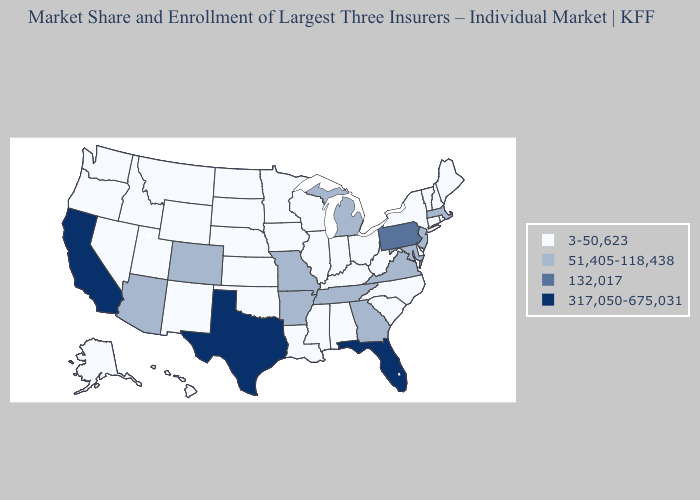Name the states that have a value in the range 132,017?
Keep it brief. Pennsylvania. Does Pennsylvania have the highest value in the Northeast?
Short answer required. Yes. Does Maine have the lowest value in the USA?
Concise answer only. Yes. Name the states that have a value in the range 132,017?
Concise answer only. Pennsylvania. Name the states that have a value in the range 3-50,623?
Give a very brief answer. Alabama, Alaska, Connecticut, Delaware, Hawaii, Idaho, Illinois, Indiana, Iowa, Kansas, Kentucky, Louisiana, Maine, Minnesota, Mississippi, Montana, Nebraska, Nevada, New Hampshire, New Mexico, New York, North Carolina, North Dakota, Ohio, Oklahoma, Oregon, Rhode Island, South Carolina, South Dakota, Utah, Vermont, Washington, West Virginia, Wisconsin, Wyoming. Which states hav the highest value in the West?
Short answer required. California. Which states have the highest value in the USA?
Concise answer only. California, Florida, Texas. What is the value of Nevada?
Short answer required. 3-50,623. Which states hav the highest value in the MidWest?
Keep it brief. Michigan, Missouri. Which states have the lowest value in the West?
Give a very brief answer. Alaska, Hawaii, Idaho, Montana, Nevada, New Mexico, Oregon, Utah, Washington, Wyoming. How many symbols are there in the legend?
Answer briefly. 4. What is the value of North Carolina?
Quick response, please. 3-50,623. Does the map have missing data?
Concise answer only. No. Name the states that have a value in the range 3-50,623?
Quick response, please. Alabama, Alaska, Connecticut, Delaware, Hawaii, Idaho, Illinois, Indiana, Iowa, Kansas, Kentucky, Louisiana, Maine, Minnesota, Mississippi, Montana, Nebraska, Nevada, New Hampshire, New Mexico, New York, North Carolina, North Dakota, Ohio, Oklahoma, Oregon, Rhode Island, South Carolina, South Dakota, Utah, Vermont, Washington, West Virginia, Wisconsin, Wyoming. Name the states that have a value in the range 132,017?
Quick response, please. Pennsylvania. 